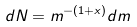<formula> <loc_0><loc_0><loc_500><loc_500>d N = m ^ { - ( 1 + x ) } d m</formula> 